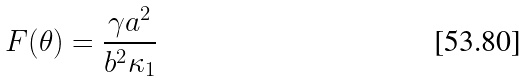<formula> <loc_0><loc_0><loc_500><loc_500>F ( \theta ) = \frac { \gamma a ^ { 2 } } { b ^ { 2 } \kappa _ { 1 } }</formula> 